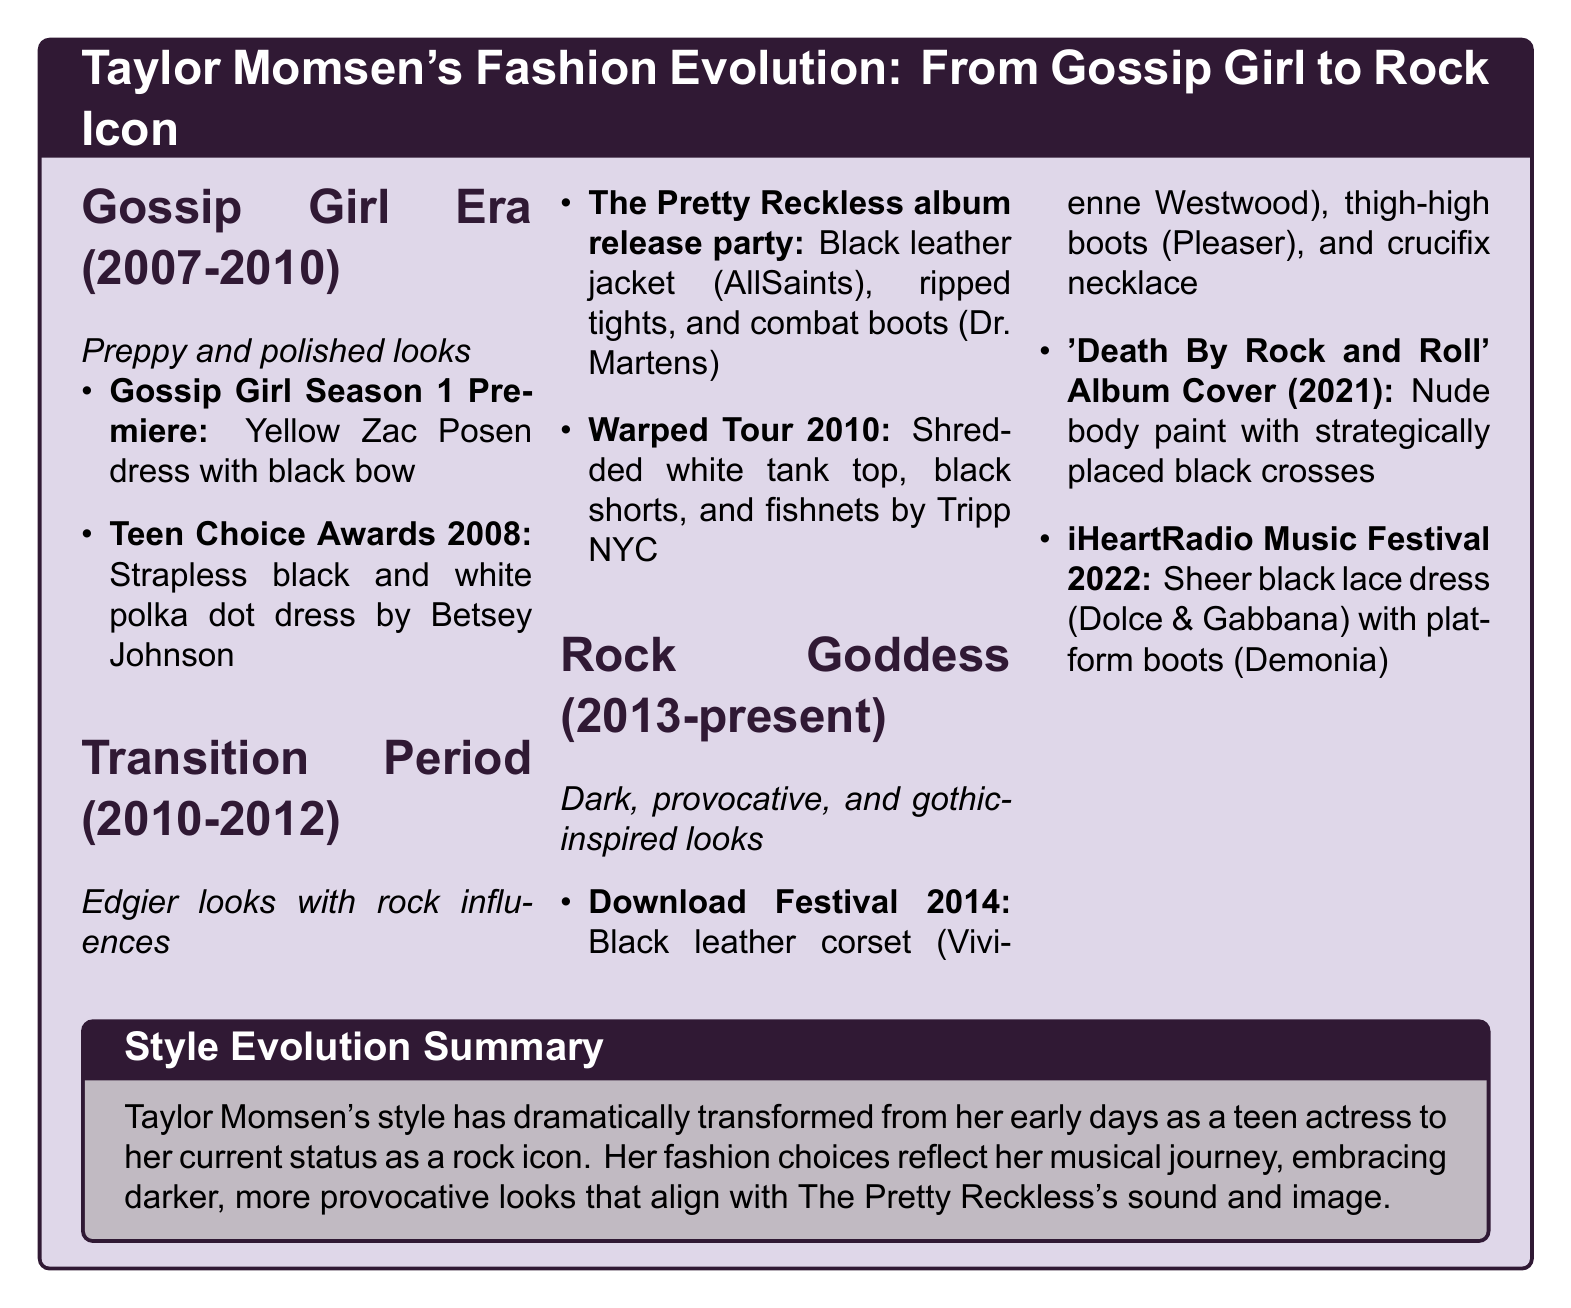what was Taylor Momsen's outfit at the Teen Choice Awards 2008? The document states that she wore a strapless black and white polka dot dress by Betsey Johnson.
Answer: strapless black and white polka dot dress by Betsey Johnson which designer created the black leather corset worn at Download Festival 2014? The document specifies that the black leather corset was designed by Vivienne Westwood.
Answer: Vivienne Westwood how many fashion eras are listed in Taylor Momsen's fashion evolution? The document outlines three distinct fashion eras in her evolution.
Answer: 3 what type of outfit did Taylor wear during the Transition Period (2010-2012)? The document describes the outfits as edgier looks with rock influences.
Answer: edgier looks with rock influences what did Taylor Momsen wear for the 'Death By Rock and Roll' album cover? According to the document, she wore nude body paint with strategically placed black crosses.
Answer: nude body paint with strategically placed black crosses which piece did Taylor wear during the iHeartRadio Music Festival 2022? The document mentions a sheer black lace dress worn during this festival.
Answer: sheer black lace dress what is the key aspect of Taylor Momsen's style evolution? The document highlights a dramatic transformation reflecting her musical journey.
Answer: dramatic transformation reflecting her musical journey who designed the sheer black lace dress from the iHeartRadio Music Festival 2022? The document specifies that the dress was designed by Dolce & Gabbana.
Answer: Dolce & Gabbana 